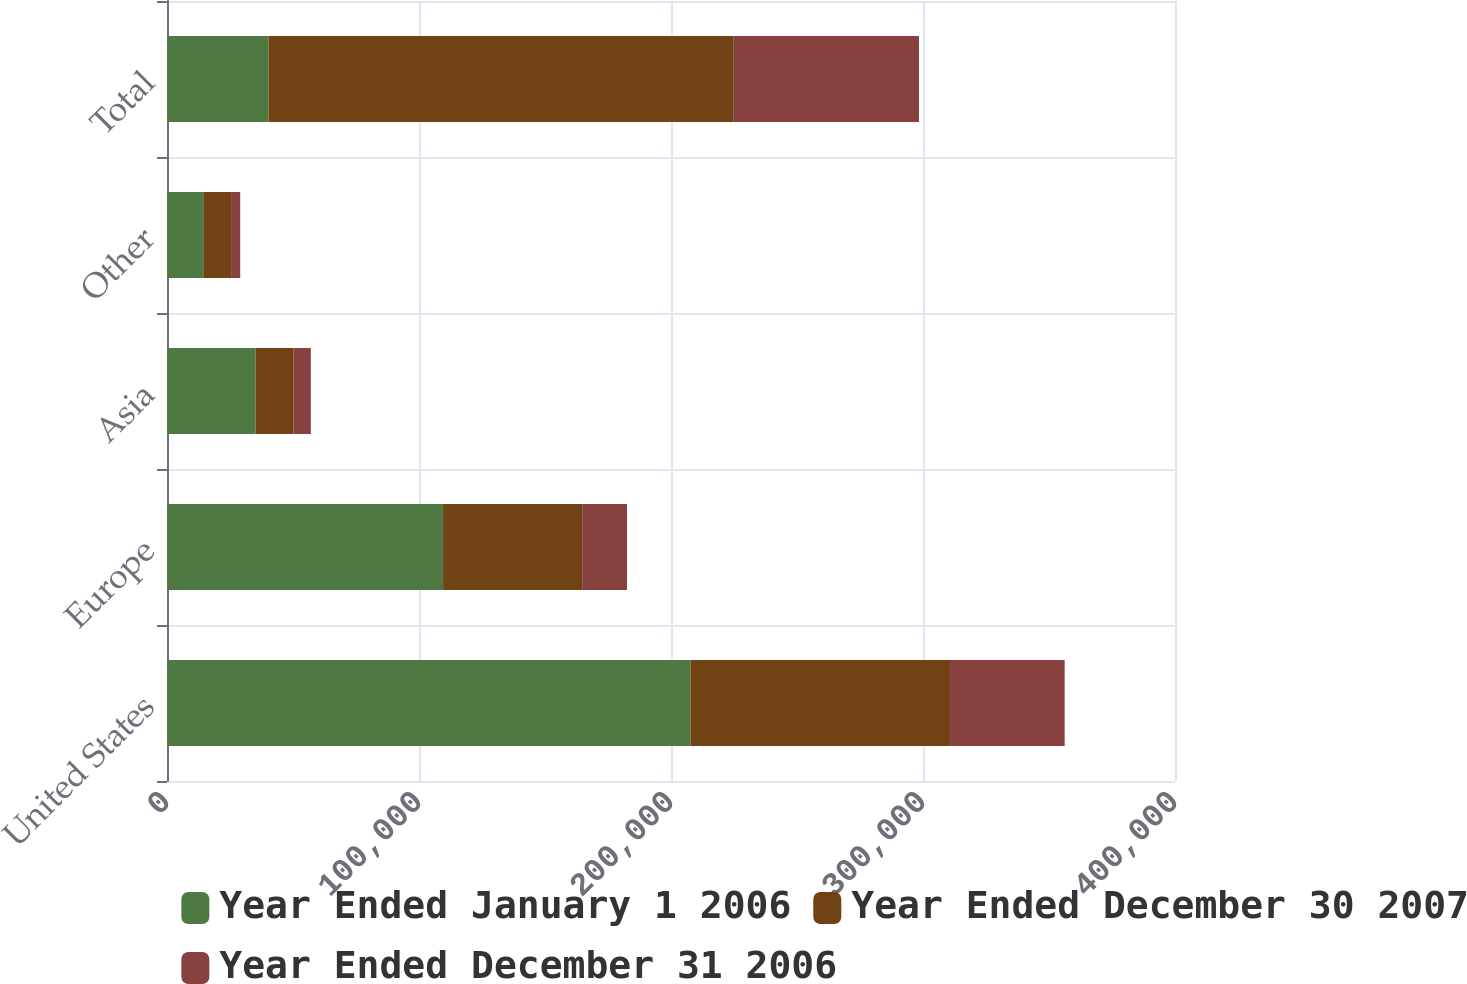Convert chart. <chart><loc_0><loc_0><loc_500><loc_500><stacked_bar_chart><ecel><fcel>United States<fcel>Europe<fcel>Asia<fcel>Other<fcel>Total<nl><fcel>Year Ended January 1 2006<fcel>207692<fcel>109556<fcel>35155<fcel>14396<fcel>40317.5<nl><fcel>Year Ended December 30 2007<fcel>103043<fcel>55440<fcel>15070<fcel>11033<fcel>184586<nl><fcel>Year Ended December 31 2006<fcel>45480<fcel>17551<fcel>6850<fcel>3620<fcel>73501<nl></chart> 